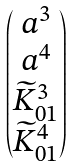<formula> <loc_0><loc_0><loc_500><loc_500>\begin{pmatrix} a ^ { 3 } \\ a ^ { 4 } \\ \widetilde { K } _ { 0 1 } ^ { 3 } \\ \widetilde { K } _ { 0 1 } ^ { 4 } \end{pmatrix}</formula> 